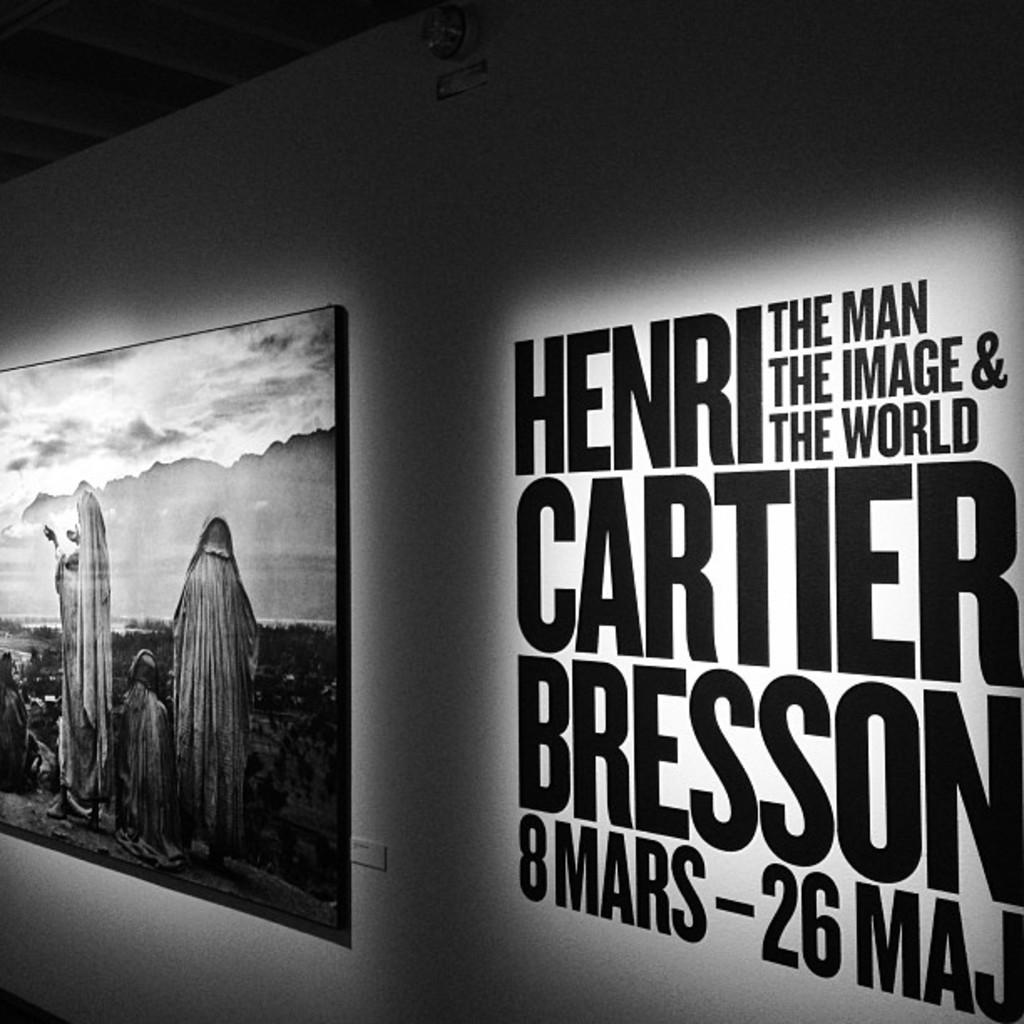<image>
Provide a brief description of the given image. An art exhibit by the famous Henri Cartier Bresson is being displayed. 